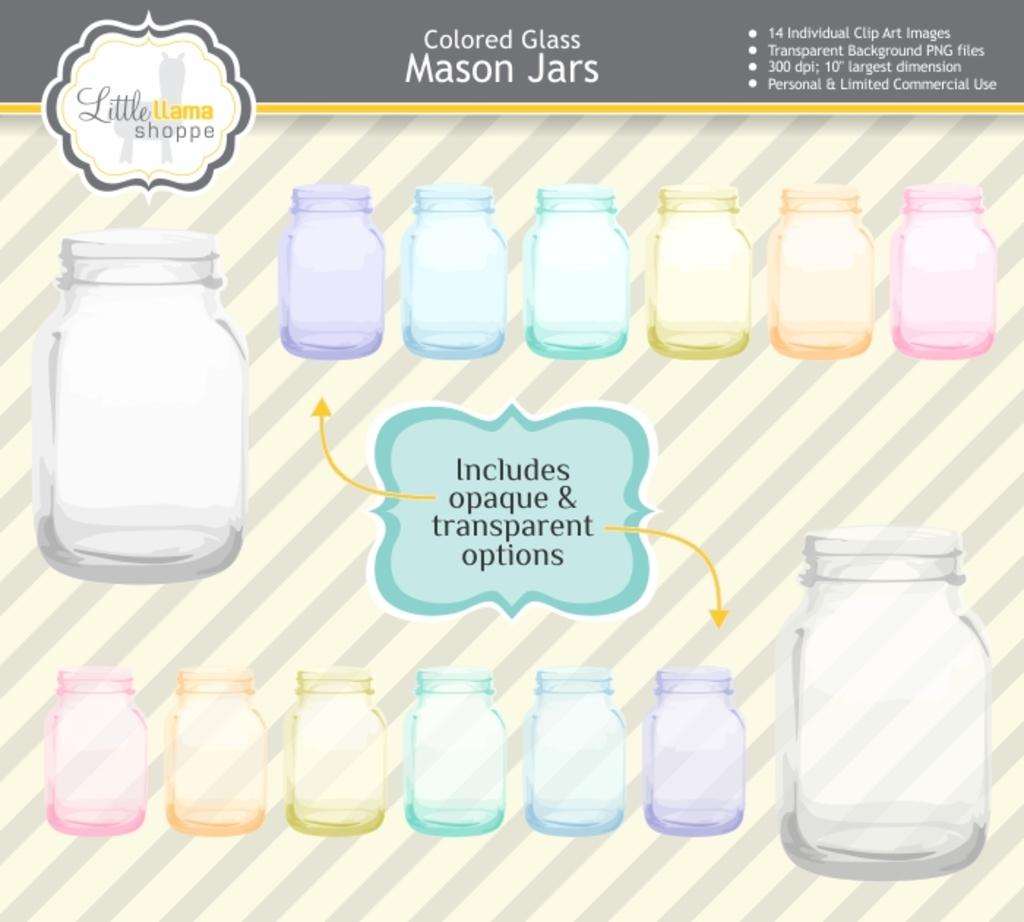Provide a one-sentence caption for the provided image. An advertisment for different colored Mason Jars with a notice saying that they include both opaque and transparent options. 